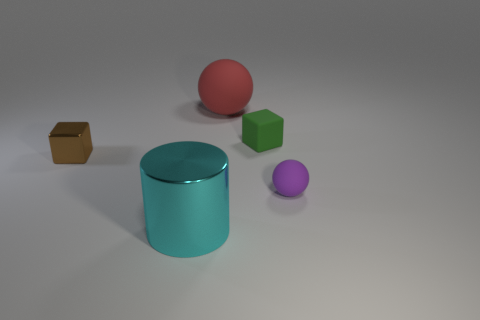Add 1 tiny brown blocks. How many objects exist? 6 Subtract all balls. How many objects are left? 3 Add 3 small blocks. How many small blocks exist? 5 Subtract 1 cyan cylinders. How many objects are left? 4 Subtract all green objects. Subtract all blocks. How many objects are left? 2 Add 2 shiny objects. How many shiny objects are left? 4 